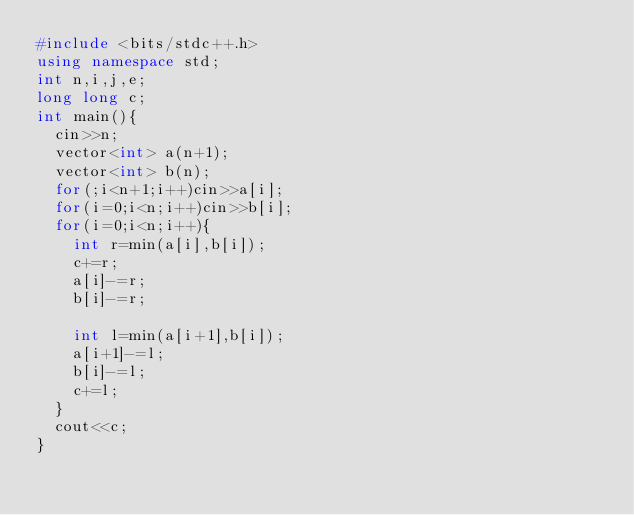Convert code to text. <code><loc_0><loc_0><loc_500><loc_500><_C++_>#include <bits/stdc++.h>
using namespace std;
int n,i,j,e;
long long c;
int main(){
  cin>>n;
  vector<int> a(n+1);
  vector<int> b(n);
  for(;i<n+1;i++)cin>>a[i];
  for(i=0;i<n;i++)cin>>b[i];
  for(i=0;i<n;i++){
    int r=min(a[i],b[i]);
    c+=r;
    a[i]-=r;
    b[i]-=r;

    int l=min(a[i+1],b[i]);
    a[i+1]-=l;
    b[i]-=l;
    c+=l;
  }
  cout<<c;
}</code> 